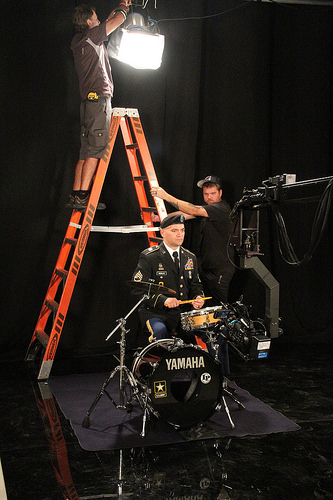<image>
Is the millitary man on the ladder? No. The millitary man is not positioned on the ladder. They may be near each other, but the millitary man is not supported by or resting on top of the ladder. 